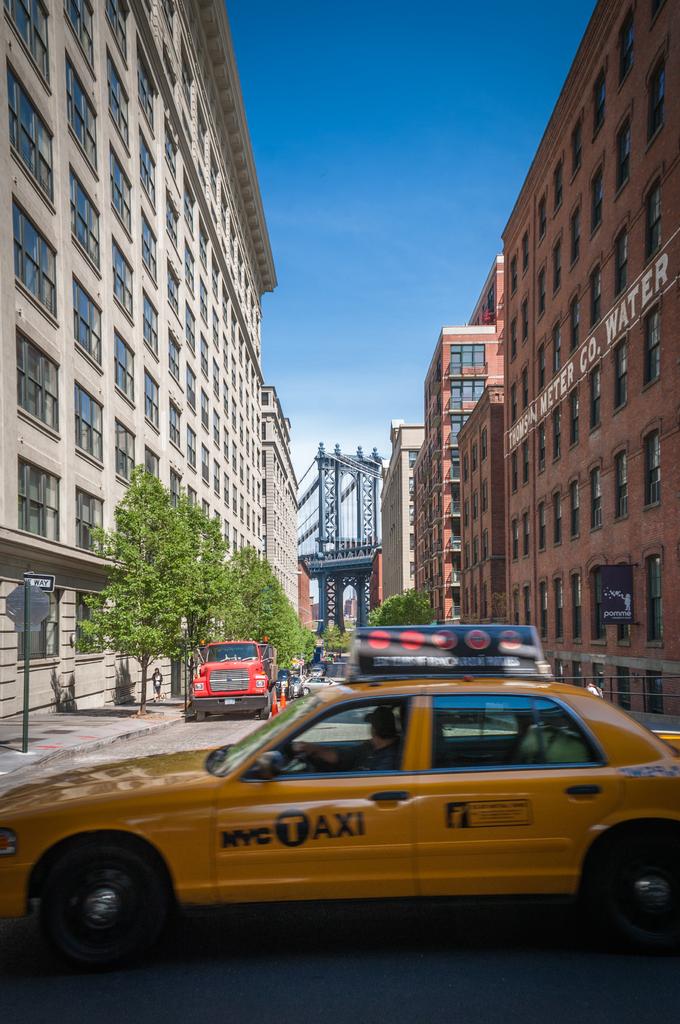What city is this taxi working in?
Give a very brief answer. Nyc. What´s the name of the building  on the right?
Provide a short and direct response. Thomson meter co. water. 